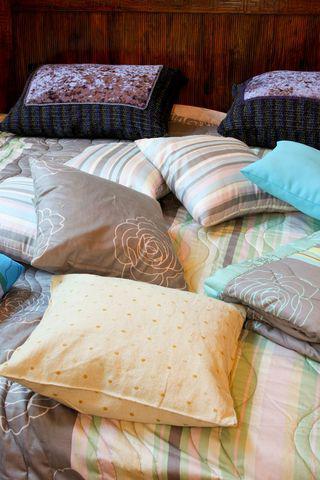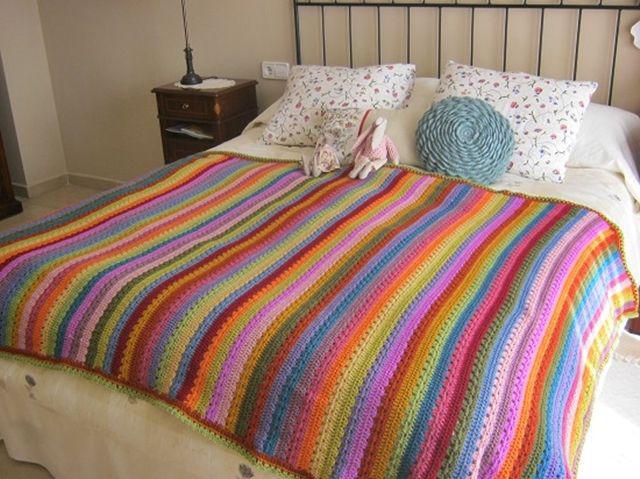The first image is the image on the left, the second image is the image on the right. Analyze the images presented: Is the assertion "There are stuffed animals on a bed." valid? Answer yes or no. Yes. The first image is the image on the left, the second image is the image on the right. Examine the images to the left and right. Is the description "A pale neutral-colored sofa is topped with a row of at least three colorful square throw pillows in one image." accurate? Answer yes or no. No. 